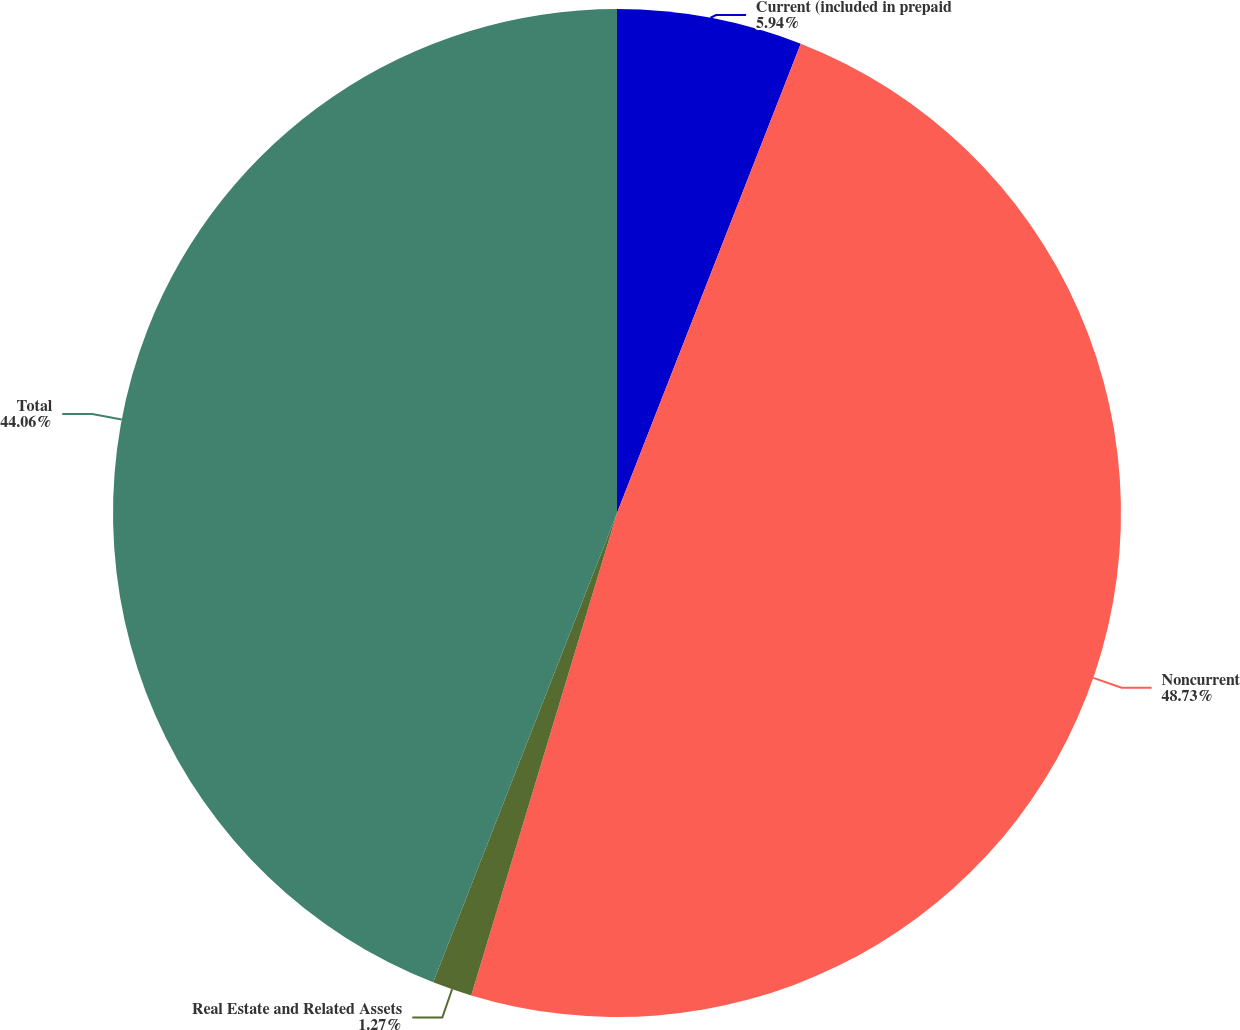Convert chart to OTSL. <chart><loc_0><loc_0><loc_500><loc_500><pie_chart><fcel>Current (included in prepaid<fcel>Noncurrent<fcel>Real Estate and Related Assets<fcel>Total<nl><fcel>5.94%<fcel>48.73%<fcel>1.27%<fcel>44.06%<nl></chart> 